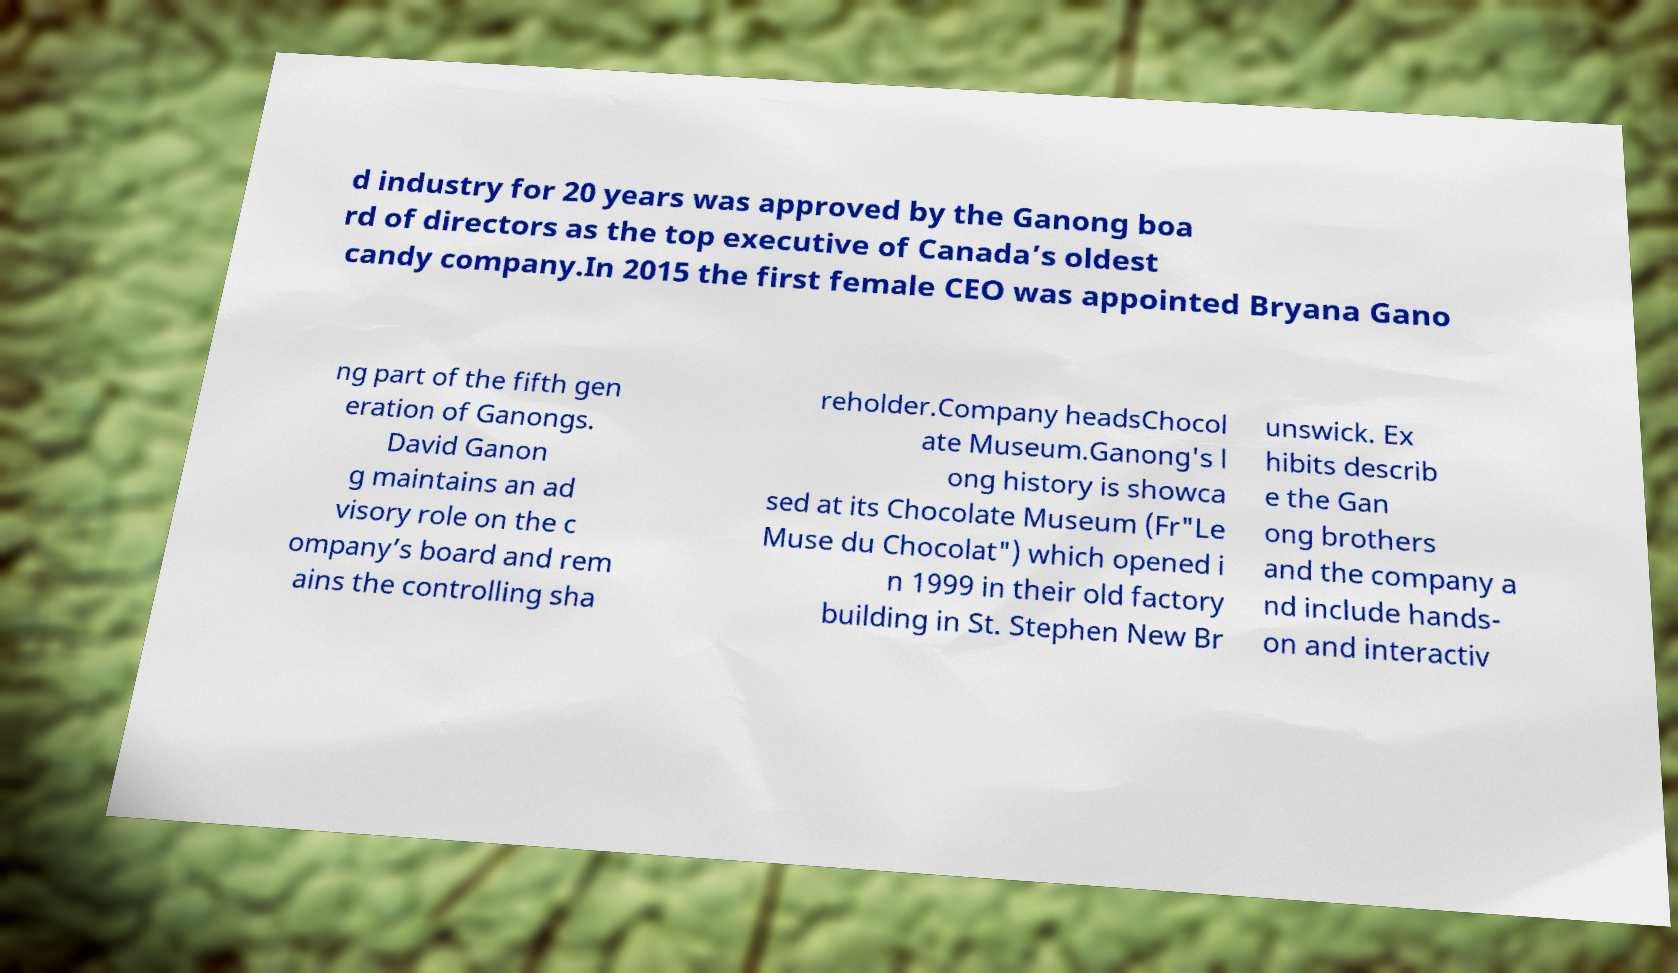I need the written content from this picture converted into text. Can you do that? d industry for 20 years was approved by the Ganong boa rd of directors as the top executive of Canada’s oldest candy company.In 2015 the first female CEO was appointed Bryana Gano ng part of the fifth gen eration of Ganongs. David Ganon g maintains an ad visory role on the c ompany’s board and rem ains the controlling sha reholder.Company headsChocol ate Museum.Ganong's l ong history is showca sed at its Chocolate Museum (Fr"Le Muse du Chocolat") which opened i n 1999 in their old factory building in St. Stephen New Br unswick. Ex hibits describ e the Gan ong brothers and the company a nd include hands- on and interactiv 